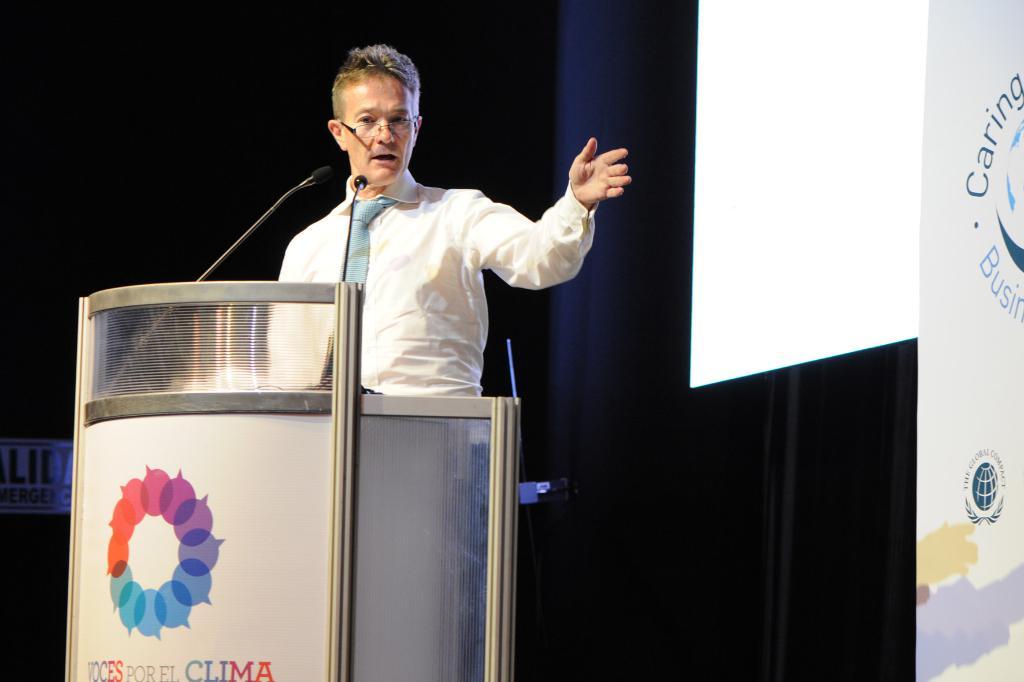What company is this?
Offer a very short reply. Clima. Does it say caring and business in the upper right side ?
Offer a very short reply. Yes. 